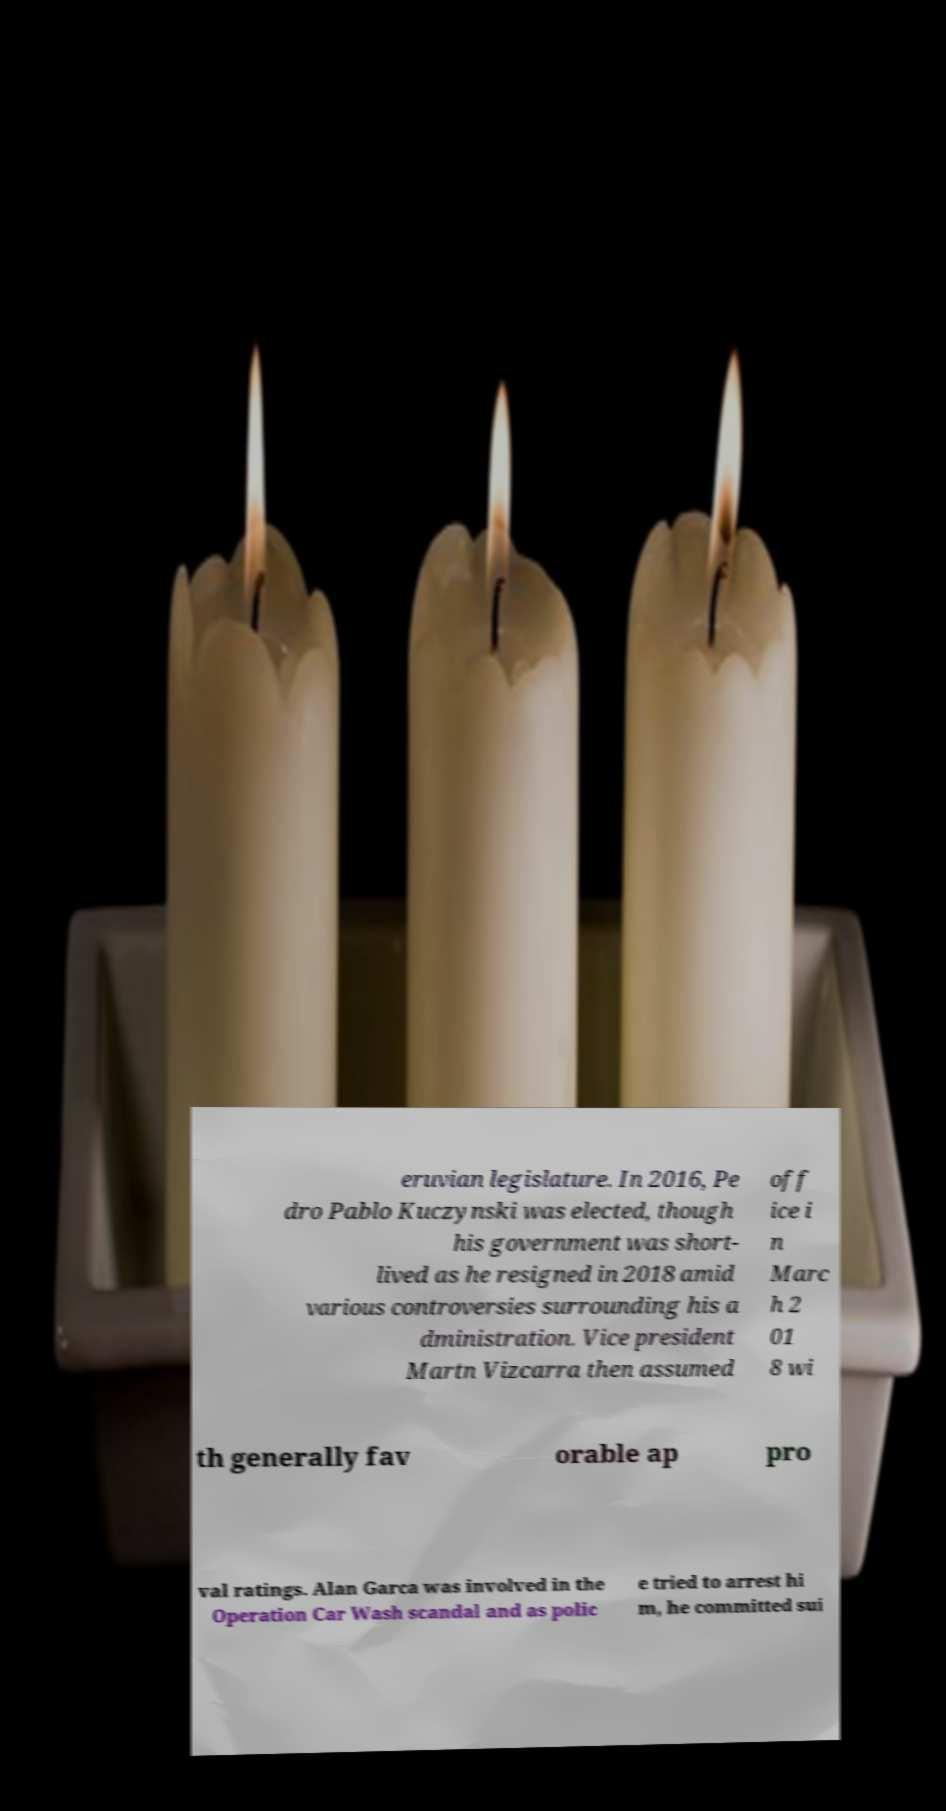Can you read and provide the text displayed in the image?This photo seems to have some interesting text. Can you extract and type it out for me? eruvian legislature. In 2016, Pe dro Pablo Kuczynski was elected, though his government was short- lived as he resigned in 2018 amid various controversies surrounding his a dministration. Vice president Martn Vizcarra then assumed off ice i n Marc h 2 01 8 wi th generally fav orable ap pro val ratings. Alan Garca was involved in the Operation Car Wash scandal and as polic e tried to arrest hi m, he committed sui 